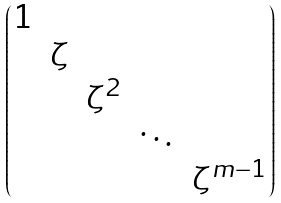<formula> <loc_0><loc_0><loc_500><loc_500>\begin{pmatrix} 1 & & & & \\ & \zeta & & & \\ & & \zeta ^ { 2 } & & \\ & & & \ddots & \\ & & & & \zeta ^ { m - 1 } \end{pmatrix}</formula> 